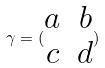Convert formula to latex. <formula><loc_0><loc_0><loc_500><loc_500>\gamma = ( \begin{matrix} a & b \\ c & d \end{matrix} )</formula> 